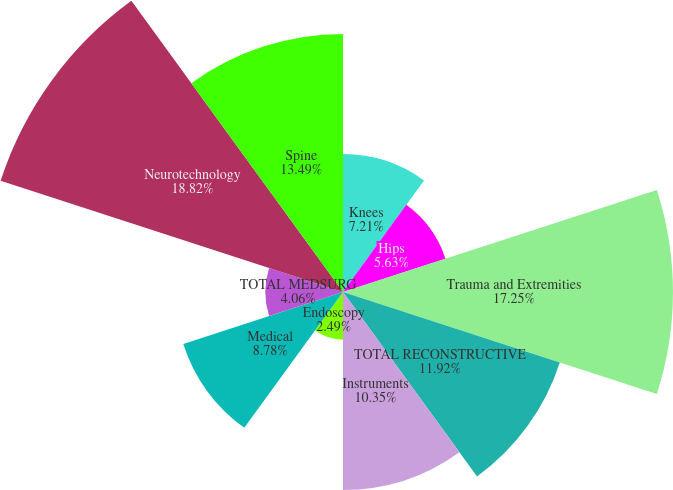Convert chart. <chart><loc_0><loc_0><loc_500><loc_500><pie_chart><fcel>Knees<fcel>Hips<fcel>Trauma and Extremities<fcel>TOTAL RECONSTRUCTIVE<fcel>Instruments<fcel>Endoscopy<fcel>Medical<fcel>TOTAL MEDSURG<fcel>Neurotechnology<fcel>Spine<nl><fcel>7.21%<fcel>5.63%<fcel>17.25%<fcel>11.92%<fcel>10.35%<fcel>2.49%<fcel>8.78%<fcel>4.06%<fcel>18.82%<fcel>13.49%<nl></chart> 